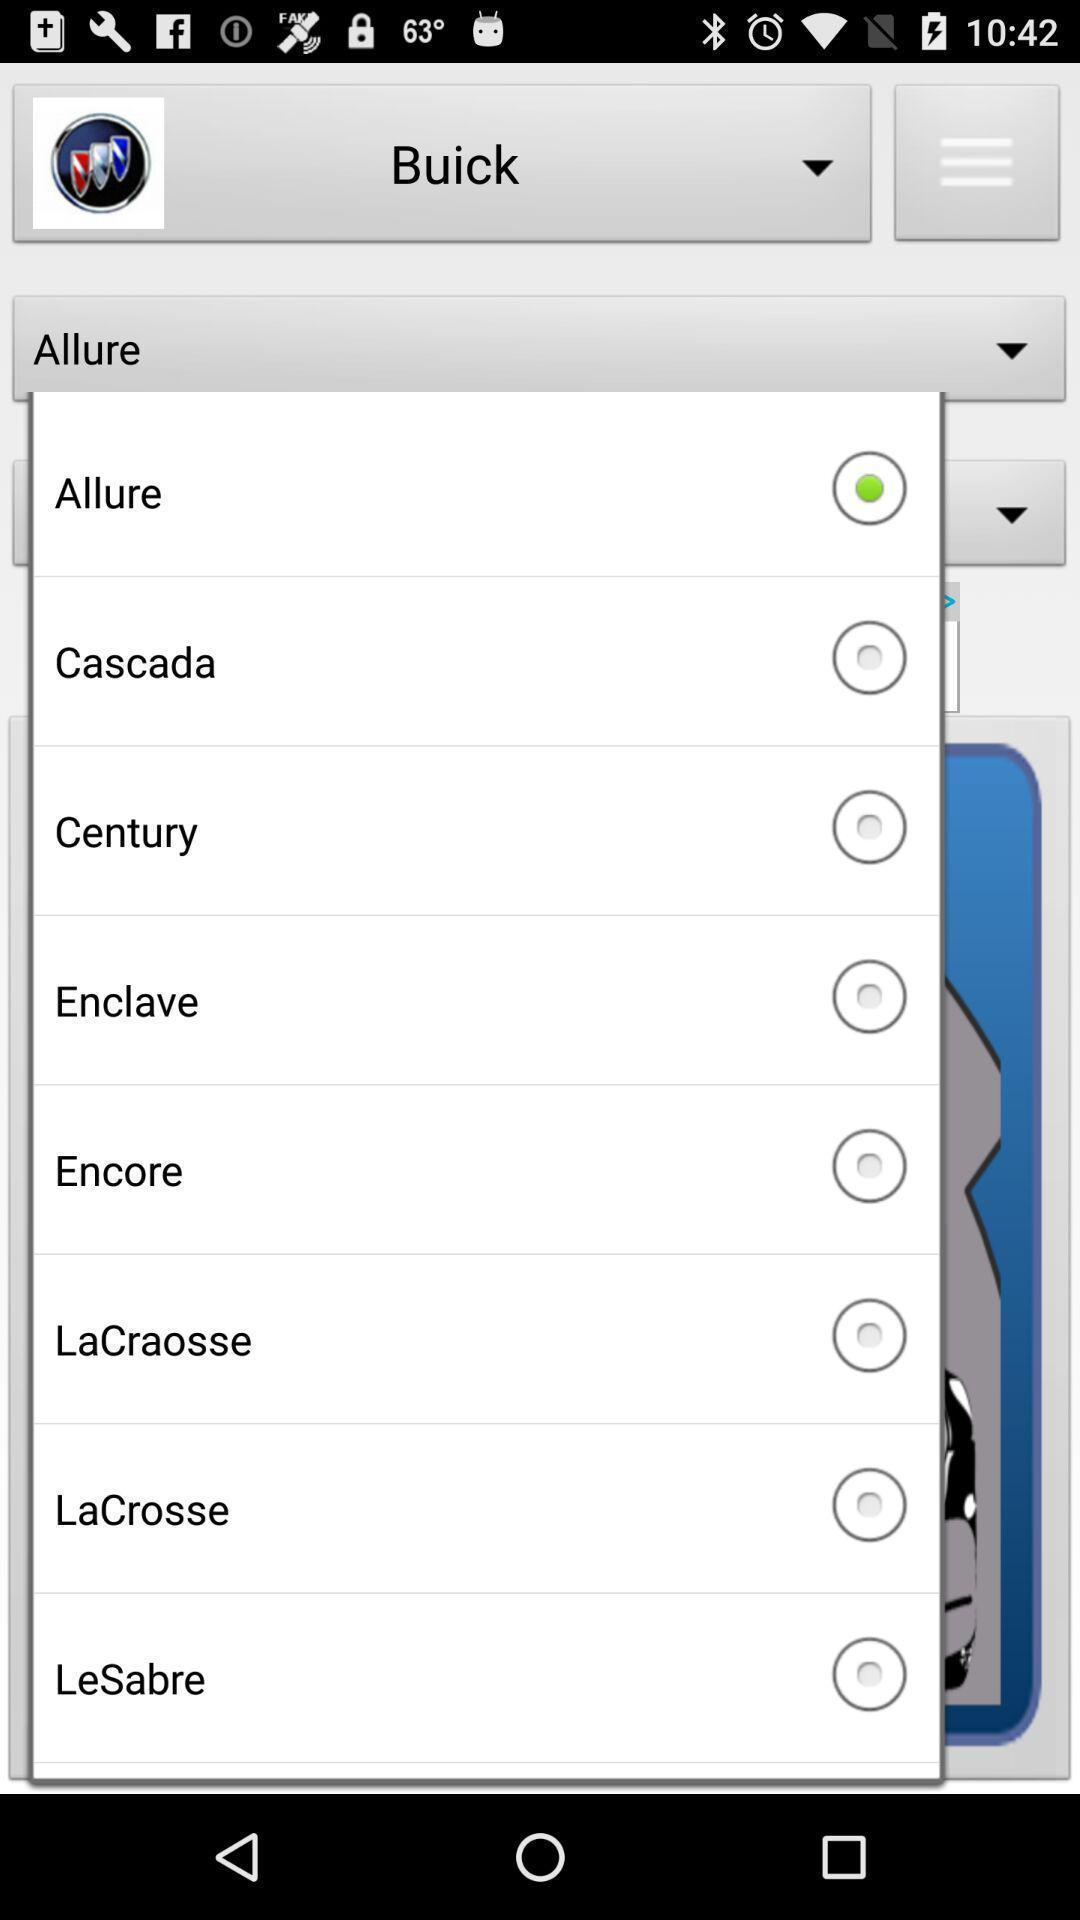Summarize the information in this screenshot. Page displays to select model of a vehicle in app. 